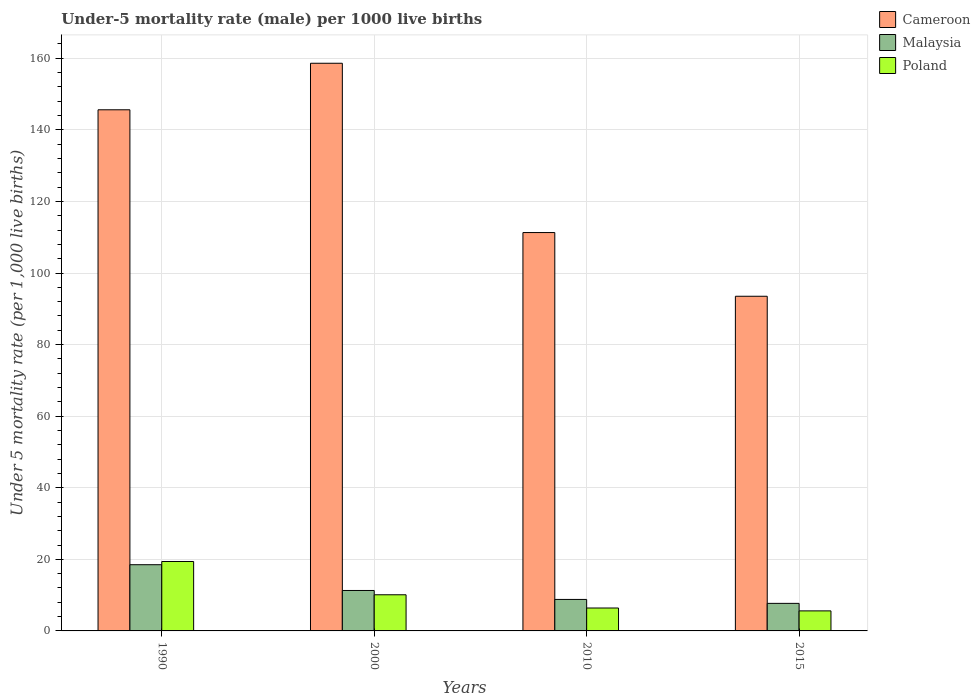Are the number of bars per tick equal to the number of legend labels?
Make the answer very short. Yes. Are the number of bars on each tick of the X-axis equal?
Ensure brevity in your answer.  Yes. How many bars are there on the 1st tick from the left?
Offer a terse response. 3. What is the label of the 3rd group of bars from the left?
Your answer should be compact. 2010. In how many cases, is the number of bars for a given year not equal to the number of legend labels?
Ensure brevity in your answer.  0. What is the under-five mortality rate in Cameroon in 2015?
Your answer should be very brief. 93.5. Across all years, what is the minimum under-five mortality rate in Cameroon?
Provide a succinct answer. 93.5. In which year was the under-five mortality rate in Poland maximum?
Provide a succinct answer. 1990. In which year was the under-five mortality rate in Malaysia minimum?
Ensure brevity in your answer.  2015. What is the total under-five mortality rate in Poland in the graph?
Provide a short and direct response. 41.5. What is the difference between the under-five mortality rate in Poland in 2000 and that in 2015?
Keep it short and to the point. 4.5. What is the difference between the under-five mortality rate in Malaysia in 2015 and the under-five mortality rate in Cameroon in 1990?
Offer a terse response. -137.9. What is the average under-five mortality rate in Cameroon per year?
Offer a terse response. 127.25. In the year 2015, what is the difference between the under-five mortality rate in Cameroon and under-five mortality rate in Malaysia?
Your response must be concise. 85.8. What is the ratio of the under-five mortality rate in Malaysia in 1990 to that in 2010?
Keep it short and to the point. 2.1. What is the difference between the highest and the second highest under-five mortality rate in Cameroon?
Make the answer very short. 13. What is the difference between the highest and the lowest under-five mortality rate in Cameroon?
Make the answer very short. 65.1. In how many years, is the under-five mortality rate in Malaysia greater than the average under-five mortality rate in Malaysia taken over all years?
Your answer should be compact. 1. What does the 1st bar from the left in 2015 represents?
Keep it short and to the point. Cameroon. Is it the case that in every year, the sum of the under-five mortality rate in Cameroon and under-five mortality rate in Poland is greater than the under-five mortality rate in Malaysia?
Ensure brevity in your answer.  Yes. How many years are there in the graph?
Your answer should be compact. 4. What is the difference between two consecutive major ticks on the Y-axis?
Keep it short and to the point. 20. Are the values on the major ticks of Y-axis written in scientific E-notation?
Your answer should be compact. No. How many legend labels are there?
Provide a short and direct response. 3. How are the legend labels stacked?
Provide a short and direct response. Vertical. What is the title of the graph?
Keep it short and to the point. Under-5 mortality rate (male) per 1000 live births. Does "Hungary" appear as one of the legend labels in the graph?
Provide a succinct answer. No. What is the label or title of the Y-axis?
Provide a short and direct response. Under 5 mortality rate (per 1,0 live births). What is the Under 5 mortality rate (per 1,000 live births) of Cameroon in 1990?
Your answer should be very brief. 145.6. What is the Under 5 mortality rate (per 1,000 live births) in Cameroon in 2000?
Give a very brief answer. 158.6. What is the Under 5 mortality rate (per 1,000 live births) in Poland in 2000?
Your answer should be compact. 10.1. What is the Under 5 mortality rate (per 1,000 live births) of Cameroon in 2010?
Make the answer very short. 111.3. What is the Under 5 mortality rate (per 1,000 live births) of Cameroon in 2015?
Provide a short and direct response. 93.5. What is the Under 5 mortality rate (per 1,000 live births) of Malaysia in 2015?
Provide a succinct answer. 7.7. What is the Under 5 mortality rate (per 1,000 live births) in Poland in 2015?
Provide a short and direct response. 5.6. Across all years, what is the maximum Under 5 mortality rate (per 1,000 live births) of Cameroon?
Give a very brief answer. 158.6. Across all years, what is the maximum Under 5 mortality rate (per 1,000 live births) in Malaysia?
Ensure brevity in your answer.  18.5. Across all years, what is the minimum Under 5 mortality rate (per 1,000 live births) of Cameroon?
Your answer should be very brief. 93.5. Across all years, what is the minimum Under 5 mortality rate (per 1,000 live births) in Malaysia?
Your response must be concise. 7.7. What is the total Under 5 mortality rate (per 1,000 live births) in Cameroon in the graph?
Provide a short and direct response. 509. What is the total Under 5 mortality rate (per 1,000 live births) of Malaysia in the graph?
Your response must be concise. 46.3. What is the total Under 5 mortality rate (per 1,000 live births) in Poland in the graph?
Keep it short and to the point. 41.5. What is the difference between the Under 5 mortality rate (per 1,000 live births) in Cameroon in 1990 and that in 2010?
Your answer should be very brief. 34.3. What is the difference between the Under 5 mortality rate (per 1,000 live births) in Cameroon in 1990 and that in 2015?
Ensure brevity in your answer.  52.1. What is the difference between the Under 5 mortality rate (per 1,000 live births) of Malaysia in 1990 and that in 2015?
Offer a very short reply. 10.8. What is the difference between the Under 5 mortality rate (per 1,000 live births) in Cameroon in 2000 and that in 2010?
Keep it short and to the point. 47.3. What is the difference between the Under 5 mortality rate (per 1,000 live births) of Malaysia in 2000 and that in 2010?
Offer a terse response. 2.5. What is the difference between the Under 5 mortality rate (per 1,000 live births) in Poland in 2000 and that in 2010?
Offer a very short reply. 3.7. What is the difference between the Under 5 mortality rate (per 1,000 live births) in Cameroon in 2000 and that in 2015?
Offer a terse response. 65.1. What is the difference between the Under 5 mortality rate (per 1,000 live births) of Poland in 2000 and that in 2015?
Ensure brevity in your answer.  4.5. What is the difference between the Under 5 mortality rate (per 1,000 live births) in Cameroon in 1990 and the Under 5 mortality rate (per 1,000 live births) in Malaysia in 2000?
Ensure brevity in your answer.  134.3. What is the difference between the Under 5 mortality rate (per 1,000 live births) of Cameroon in 1990 and the Under 5 mortality rate (per 1,000 live births) of Poland in 2000?
Provide a succinct answer. 135.5. What is the difference between the Under 5 mortality rate (per 1,000 live births) in Malaysia in 1990 and the Under 5 mortality rate (per 1,000 live births) in Poland in 2000?
Offer a very short reply. 8.4. What is the difference between the Under 5 mortality rate (per 1,000 live births) of Cameroon in 1990 and the Under 5 mortality rate (per 1,000 live births) of Malaysia in 2010?
Give a very brief answer. 136.8. What is the difference between the Under 5 mortality rate (per 1,000 live births) of Cameroon in 1990 and the Under 5 mortality rate (per 1,000 live births) of Poland in 2010?
Keep it short and to the point. 139.2. What is the difference between the Under 5 mortality rate (per 1,000 live births) of Cameroon in 1990 and the Under 5 mortality rate (per 1,000 live births) of Malaysia in 2015?
Ensure brevity in your answer.  137.9. What is the difference between the Under 5 mortality rate (per 1,000 live births) in Cameroon in 1990 and the Under 5 mortality rate (per 1,000 live births) in Poland in 2015?
Give a very brief answer. 140. What is the difference between the Under 5 mortality rate (per 1,000 live births) of Malaysia in 1990 and the Under 5 mortality rate (per 1,000 live births) of Poland in 2015?
Offer a terse response. 12.9. What is the difference between the Under 5 mortality rate (per 1,000 live births) of Cameroon in 2000 and the Under 5 mortality rate (per 1,000 live births) of Malaysia in 2010?
Offer a very short reply. 149.8. What is the difference between the Under 5 mortality rate (per 1,000 live births) in Cameroon in 2000 and the Under 5 mortality rate (per 1,000 live births) in Poland in 2010?
Your response must be concise. 152.2. What is the difference between the Under 5 mortality rate (per 1,000 live births) of Malaysia in 2000 and the Under 5 mortality rate (per 1,000 live births) of Poland in 2010?
Make the answer very short. 4.9. What is the difference between the Under 5 mortality rate (per 1,000 live births) of Cameroon in 2000 and the Under 5 mortality rate (per 1,000 live births) of Malaysia in 2015?
Provide a succinct answer. 150.9. What is the difference between the Under 5 mortality rate (per 1,000 live births) in Cameroon in 2000 and the Under 5 mortality rate (per 1,000 live births) in Poland in 2015?
Your answer should be compact. 153. What is the difference between the Under 5 mortality rate (per 1,000 live births) of Malaysia in 2000 and the Under 5 mortality rate (per 1,000 live births) of Poland in 2015?
Provide a succinct answer. 5.7. What is the difference between the Under 5 mortality rate (per 1,000 live births) of Cameroon in 2010 and the Under 5 mortality rate (per 1,000 live births) of Malaysia in 2015?
Your response must be concise. 103.6. What is the difference between the Under 5 mortality rate (per 1,000 live births) of Cameroon in 2010 and the Under 5 mortality rate (per 1,000 live births) of Poland in 2015?
Your response must be concise. 105.7. What is the difference between the Under 5 mortality rate (per 1,000 live births) of Malaysia in 2010 and the Under 5 mortality rate (per 1,000 live births) of Poland in 2015?
Provide a short and direct response. 3.2. What is the average Under 5 mortality rate (per 1,000 live births) of Cameroon per year?
Provide a succinct answer. 127.25. What is the average Under 5 mortality rate (per 1,000 live births) of Malaysia per year?
Ensure brevity in your answer.  11.57. What is the average Under 5 mortality rate (per 1,000 live births) of Poland per year?
Ensure brevity in your answer.  10.38. In the year 1990, what is the difference between the Under 5 mortality rate (per 1,000 live births) of Cameroon and Under 5 mortality rate (per 1,000 live births) of Malaysia?
Ensure brevity in your answer.  127.1. In the year 1990, what is the difference between the Under 5 mortality rate (per 1,000 live births) of Cameroon and Under 5 mortality rate (per 1,000 live births) of Poland?
Give a very brief answer. 126.2. In the year 2000, what is the difference between the Under 5 mortality rate (per 1,000 live births) in Cameroon and Under 5 mortality rate (per 1,000 live births) in Malaysia?
Your answer should be compact. 147.3. In the year 2000, what is the difference between the Under 5 mortality rate (per 1,000 live births) in Cameroon and Under 5 mortality rate (per 1,000 live births) in Poland?
Your answer should be compact. 148.5. In the year 2010, what is the difference between the Under 5 mortality rate (per 1,000 live births) in Cameroon and Under 5 mortality rate (per 1,000 live births) in Malaysia?
Offer a very short reply. 102.5. In the year 2010, what is the difference between the Under 5 mortality rate (per 1,000 live births) of Cameroon and Under 5 mortality rate (per 1,000 live births) of Poland?
Offer a terse response. 104.9. In the year 2010, what is the difference between the Under 5 mortality rate (per 1,000 live births) of Malaysia and Under 5 mortality rate (per 1,000 live births) of Poland?
Offer a very short reply. 2.4. In the year 2015, what is the difference between the Under 5 mortality rate (per 1,000 live births) of Cameroon and Under 5 mortality rate (per 1,000 live births) of Malaysia?
Provide a succinct answer. 85.8. In the year 2015, what is the difference between the Under 5 mortality rate (per 1,000 live births) in Cameroon and Under 5 mortality rate (per 1,000 live births) in Poland?
Offer a very short reply. 87.9. In the year 2015, what is the difference between the Under 5 mortality rate (per 1,000 live births) of Malaysia and Under 5 mortality rate (per 1,000 live births) of Poland?
Your response must be concise. 2.1. What is the ratio of the Under 5 mortality rate (per 1,000 live births) in Cameroon in 1990 to that in 2000?
Keep it short and to the point. 0.92. What is the ratio of the Under 5 mortality rate (per 1,000 live births) of Malaysia in 1990 to that in 2000?
Offer a very short reply. 1.64. What is the ratio of the Under 5 mortality rate (per 1,000 live births) of Poland in 1990 to that in 2000?
Provide a succinct answer. 1.92. What is the ratio of the Under 5 mortality rate (per 1,000 live births) in Cameroon in 1990 to that in 2010?
Keep it short and to the point. 1.31. What is the ratio of the Under 5 mortality rate (per 1,000 live births) in Malaysia in 1990 to that in 2010?
Make the answer very short. 2.1. What is the ratio of the Under 5 mortality rate (per 1,000 live births) of Poland in 1990 to that in 2010?
Keep it short and to the point. 3.03. What is the ratio of the Under 5 mortality rate (per 1,000 live births) of Cameroon in 1990 to that in 2015?
Offer a very short reply. 1.56. What is the ratio of the Under 5 mortality rate (per 1,000 live births) in Malaysia in 1990 to that in 2015?
Provide a short and direct response. 2.4. What is the ratio of the Under 5 mortality rate (per 1,000 live births) of Poland in 1990 to that in 2015?
Provide a succinct answer. 3.46. What is the ratio of the Under 5 mortality rate (per 1,000 live births) in Cameroon in 2000 to that in 2010?
Provide a short and direct response. 1.43. What is the ratio of the Under 5 mortality rate (per 1,000 live births) in Malaysia in 2000 to that in 2010?
Your answer should be compact. 1.28. What is the ratio of the Under 5 mortality rate (per 1,000 live births) of Poland in 2000 to that in 2010?
Make the answer very short. 1.58. What is the ratio of the Under 5 mortality rate (per 1,000 live births) of Cameroon in 2000 to that in 2015?
Your response must be concise. 1.7. What is the ratio of the Under 5 mortality rate (per 1,000 live births) in Malaysia in 2000 to that in 2015?
Provide a short and direct response. 1.47. What is the ratio of the Under 5 mortality rate (per 1,000 live births) in Poland in 2000 to that in 2015?
Your answer should be compact. 1.8. What is the ratio of the Under 5 mortality rate (per 1,000 live births) of Cameroon in 2010 to that in 2015?
Offer a very short reply. 1.19. What is the difference between the highest and the second highest Under 5 mortality rate (per 1,000 live births) of Cameroon?
Ensure brevity in your answer.  13. What is the difference between the highest and the second highest Under 5 mortality rate (per 1,000 live births) in Malaysia?
Your answer should be compact. 7.2. What is the difference between the highest and the second highest Under 5 mortality rate (per 1,000 live births) of Poland?
Offer a very short reply. 9.3. What is the difference between the highest and the lowest Under 5 mortality rate (per 1,000 live births) of Cameroon?
Ensure brevity in your answer.  65.1. What is the difference between the highest and the lowest Under 5 mortality rate (per 1,000 live births) of Malaysia?
Your answer should be very brief. 10.8. 